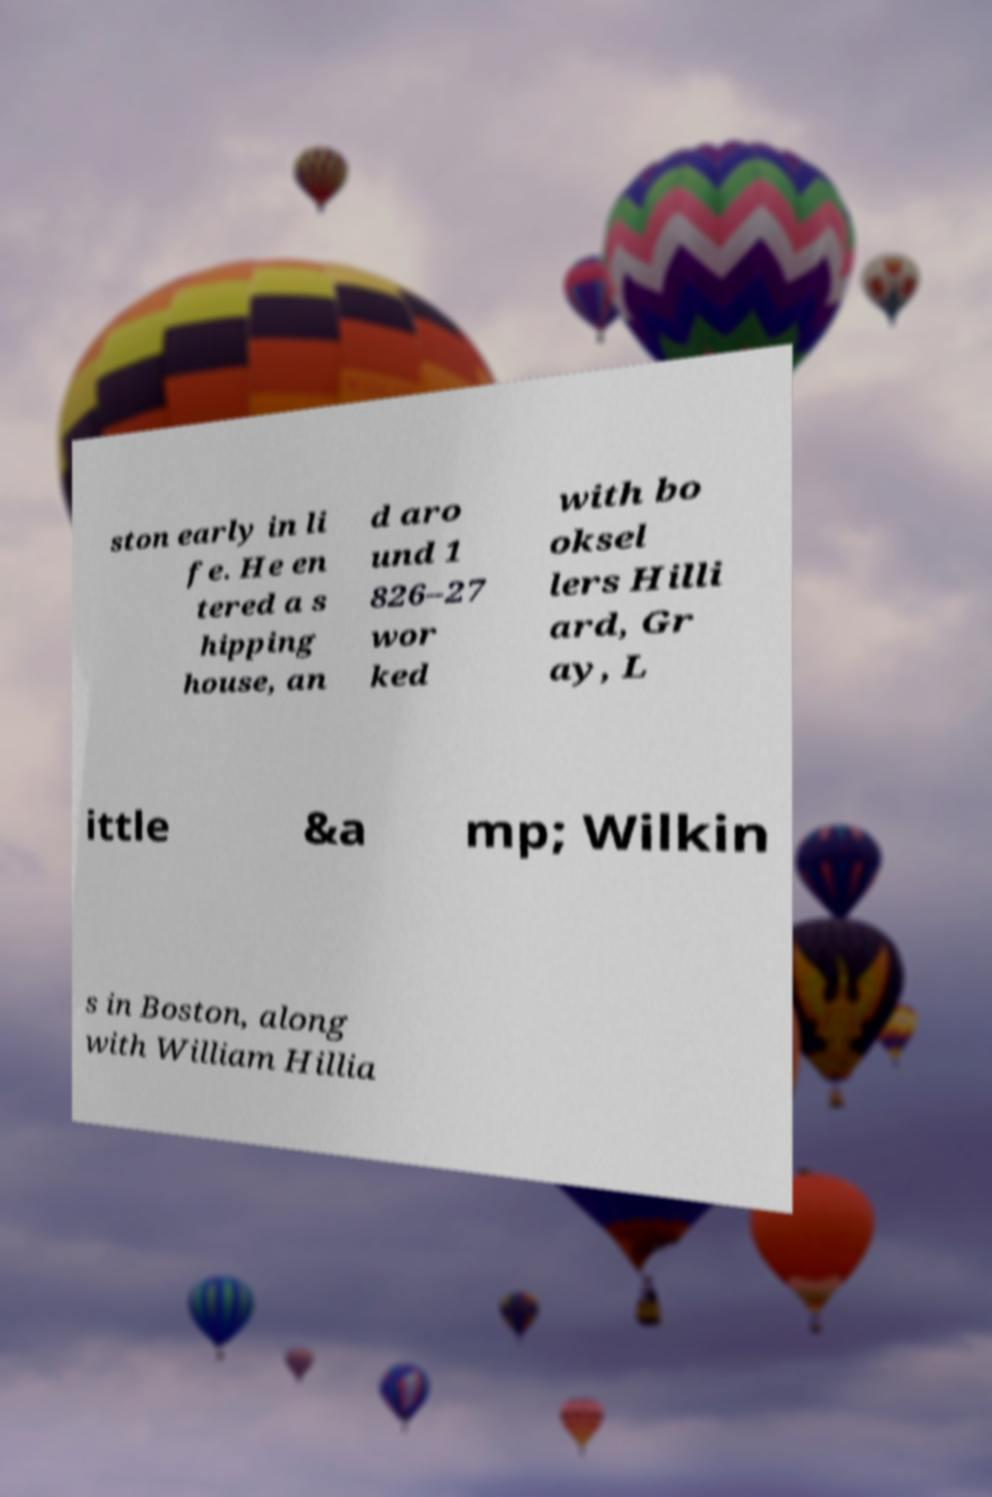Could you assist in decoding the text presented in this image and type it out clearly? ston early in li fe. He en tered a s hipping house, an d aro und 1 826–27 wor ked with bo oksel lers Hilli ard, Gr ay, L ittle &a mp; Wilkin s in Boston, along with William Hillia 